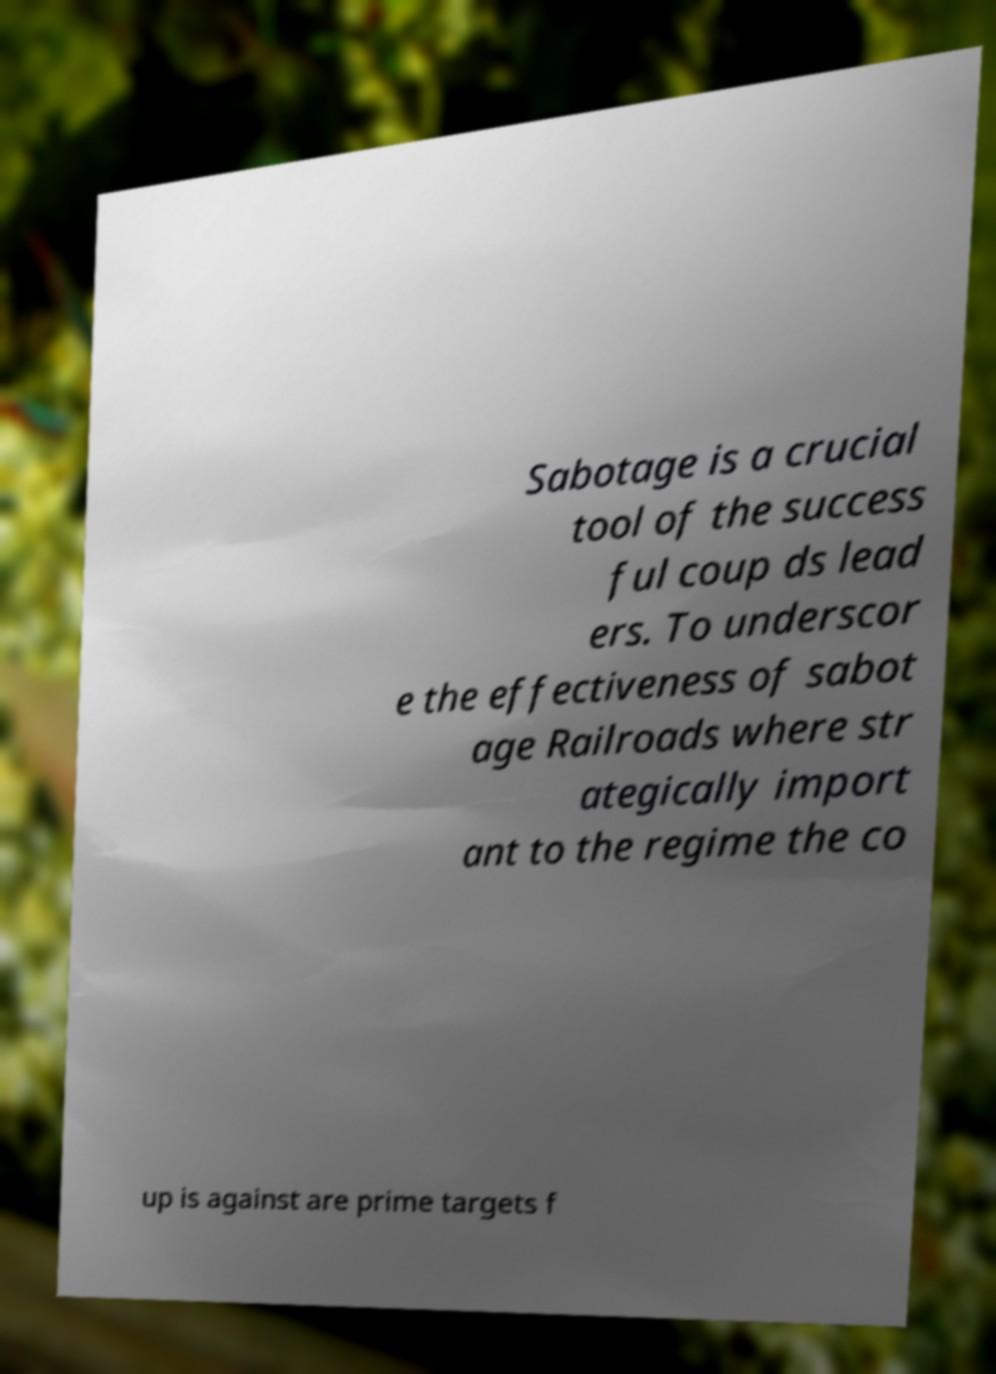Could you extract and type out the text from this image? Sabotage is a crucial tool of the success ful coup ds lead ers. To underscor e the effectiveness of sabot age Railroads where str ategically import ant to the regime the co up is against are prime targets f 